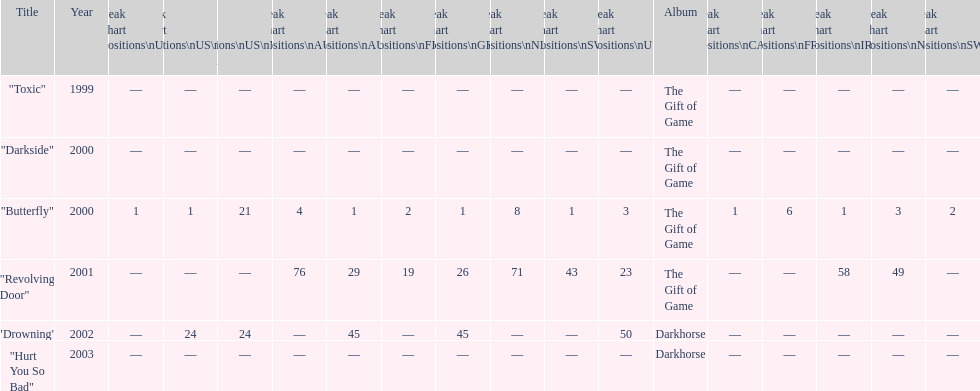By how many chart positions higher did "revolving door" peak in the uk compared to the peak position of "drowning" in the uk? 27. 